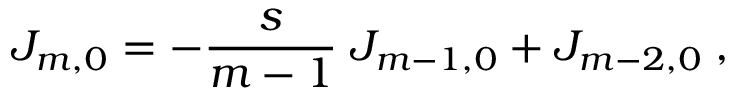Convert formula to latex. <formula><loc_0><loc_0><loc_500><loc_500>J _ { m , 0 } = - \frac { s } { m - 1 } \, J _ { m - 1 , 0 } + J _ { m - 2 , 0 } \, ,</formula> 